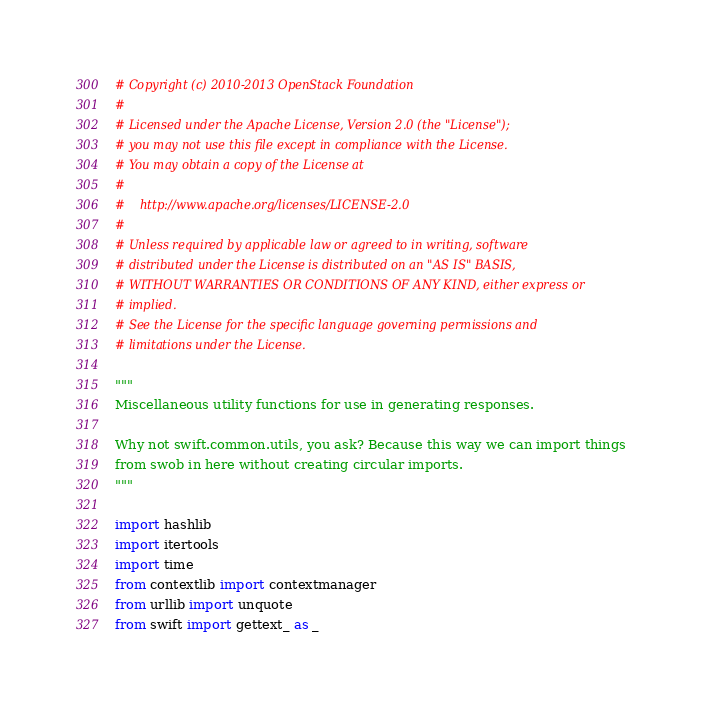<code> <loc_0><loc_0><loc_500><loc_500><_Python_># Copyright (c) 2010-2013 OpenStack Foundation
#
# Licensed under the Apache License, Version 2.0 (the "License");
# you may not use this file except in compliance with the License.
# You may obtain a copy of the License at
#
#    http://www.apache.org/licenses/LICENSE-2.0
#
# Unless required by applicable law or agreed to in writing, software
# distributed under the License is distributed on an "AS IS" BASIS,
# WITHOUT WARRANTIES OR CONDITIONS OF ANY KIND, either express or
# implied.
# See the License for the specific language governing permissions and
# limitations under the License.

"""
Miscellaneous utility functions for use in generating responses.

Why not swift.common.utils, you ask? Because this way we can import things
from swob in here without creating circular imports.
"""

import hashlib
import itertools
import time
from contextlib import contextmanager
from urllib import unquote
from swift import gettext_ as _</code> 